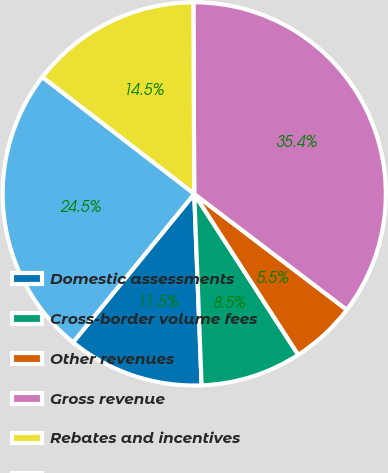<chart> <loc_0><loc_0><loc_500><loc_500><pie_chart><fcel>Domestic assessments<fcel>Cross-border volume fees<fcel>Other revenues<fcel>Gross revenue<fcel>Rebates and incentives<fcel>Net revenue<nl><fcel>11.51%<fcel>8.52%<fcel>5.53%<fcel>35.41%<fcel>14.5%<fcel>24.53%<nl></chart> 